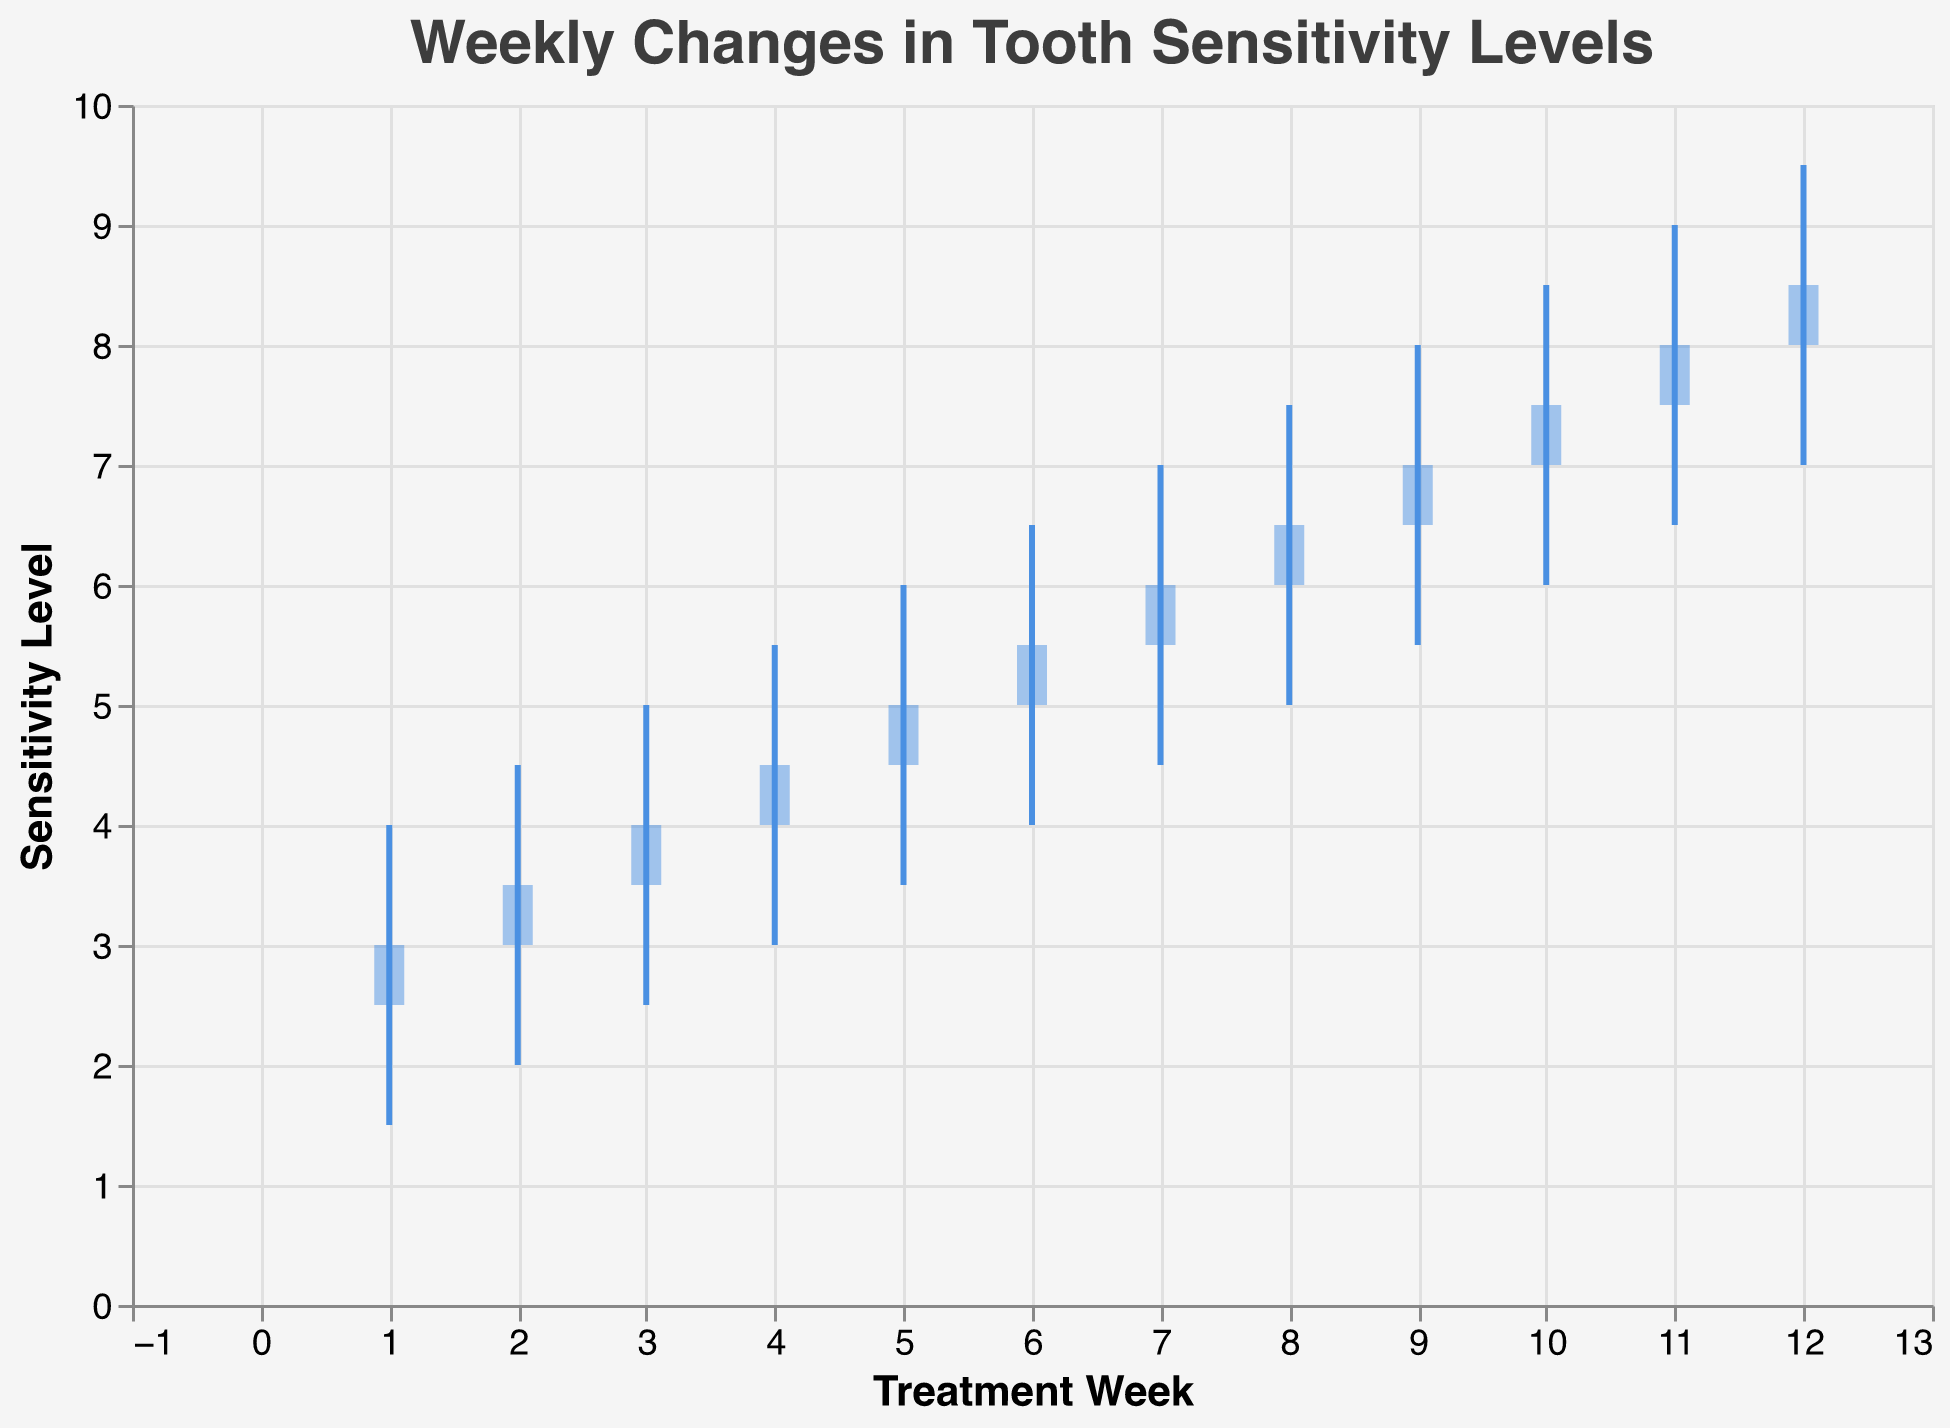What is the title of the chart? The title is usually stated at the top and specifically describes the content of the chart. Here, it is "Weekly Changes in Tooth Sensitivity Levels".
Answer: Weekly Changes in Tooth Sensitivity Levels How many weeks of data are shown in the chart? Count the number of data points along the x-axis labeled "Treatment Week". There are 12 data points, indicating 12 weeks.
Answer: 12 What was the sensitivity level range (from Low to High) in Week 1? Locate Week 1 on the x-axis and check the corresponding Low and High values on the y-axis. The Low value is 1.5 and the High value is 4.0.
Answer: 1.5 to 4.0 In which week did the sensitivity level close at 5.0? Locate the week where the Close value is 5.0 among all weeks displayed. Week 5 shows this metric.
Answer: Week 5 What was the highest sensitivity level recorded during the entire period? Survey the highest points in the High column for each week. The highest recorded value among all weeks is 9.5 in Week 12.
Answer: 9.5 During which week did the sensitivity level have its largest increase from Open to Close? Calculate the difference between Open and Close for each week and identify the largest increase. Week 12 shows the largest increase from 8.0 to 8.5, a change of 0.5.
Answer: Week 12 What is the average sensitivity level Close value over the 12 weeks? Sum all Close values and divide by the number of weeks: (3.0+3.5+4.0+4.5+5.0+5.5+6.0+6.5+7.0+7.5+8.0+8.5)=69, then divide 69 by 12.
Answer: 5.75 Which week had the lowest sensitivity level Low value across all weeks? Check the Low values for each week and identify the lowest. Week 1 has the lowest Low value of 1.5.
Answer: Week 1 How much did the sensitivity levels rise in Week 6 from the previous week in terms of the Close value? Compare the Close values of Week 6 and Week 5. Week 5’s Close is 5.0 and Week 6’s Close is 5.5. to get the difference, subtract the lower value from the higher one: 5.5 - 5.0.
Answer: 0.5 Between which weeks was there a marked increase in the High sensitivity level values by 1.5 points? Compare the High sensitivity levels between successive weeks and look for a consistent increase of 1.5. The shift from Week 2 (High 4.5) to Week 3 (High 5.0) marks a 1.5 point rise.
Answer: Week 5 to Week 6 